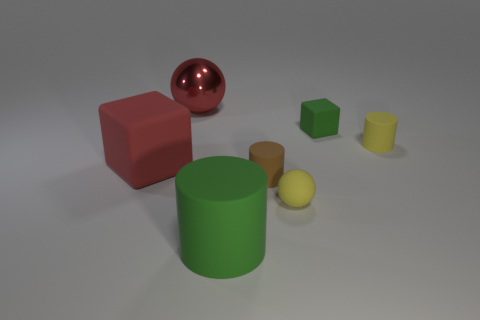Is there another large sphere that has the same color as the rubber ball?
Keep it short and to the point. No. There is a yellow object that is in front of the brown matte cylinder; is it the same size as the tiny yellow rubber cylinder?
Make the answer very short. Yes. Are there an equal number of tiny brown matte cylinders that are to the left of the green rubber cylinder and red blocks?
Ensure brevity in your answer.  No. What number of things are either blocks that are in front of the tiny matte cube or blue matte cylinders?
Your answer should be very brief. 1. There is a large thing that is behind the large green object and in front of the big sphere; what is its shape?
Ensure brevity in your answer.  Cube. What number of objects are matte objects that are to the left of the large shiny thing or big rubber things in front of the brown cylinder?
Offer a very short reply. 2. What number of other objects are there of the same size as the metal object?
Offer a terse response. 2. There is a ball in front of the tiny matte cube; is its color the same as the tiny matte cube?
Provide a short and direct response. No. What is the size of the matte cylinder that is both behind the yellow ball and left of the small matte block?
Provide a succinct answer. Small. How many large things are brown rubber cylinders or yellow objects?
Give a very brief answer. 0. 